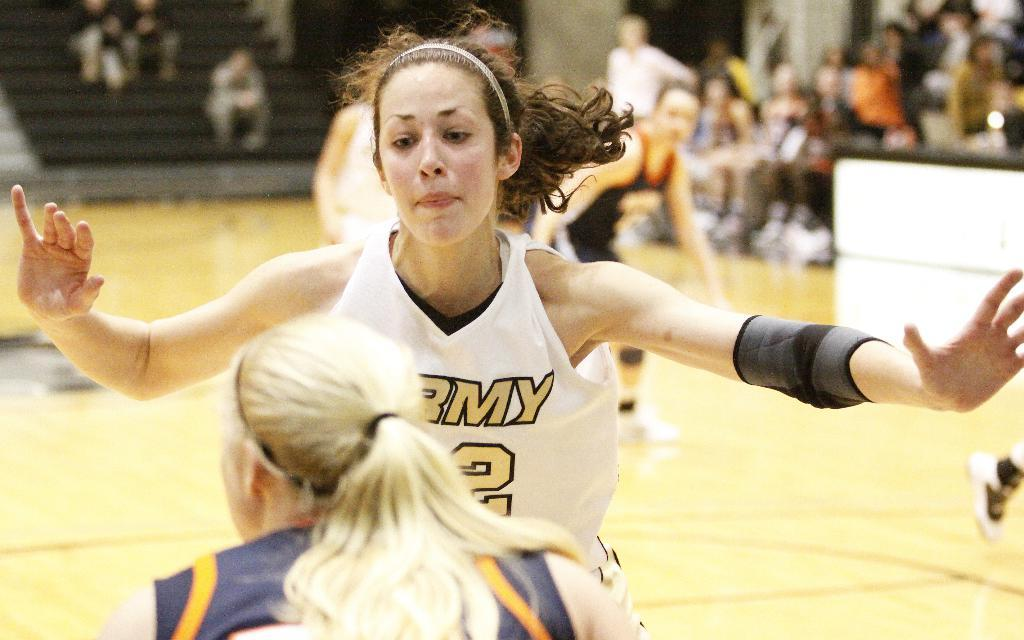What activity are the people in the image engaged in? The people in the image are playing a game. How are some of the people positioned in the image? Some people are sitting on chairs, while others are sitting on stairs. How many additions are there in the game being played in the image? There is no information about the game being played or any additions involved in the image. Can you see a tiger in the image? No, there is no tiger present in the image. 